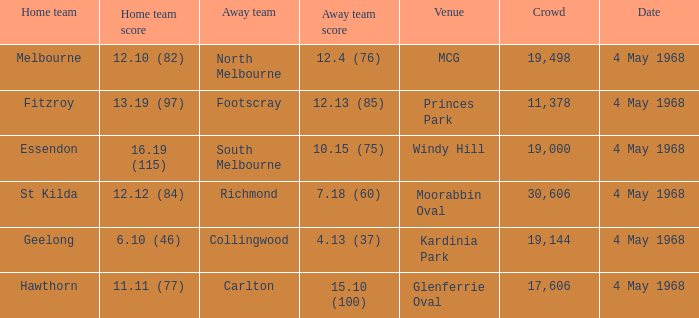What away team played at Kardinia Park? 4.13 (37). 